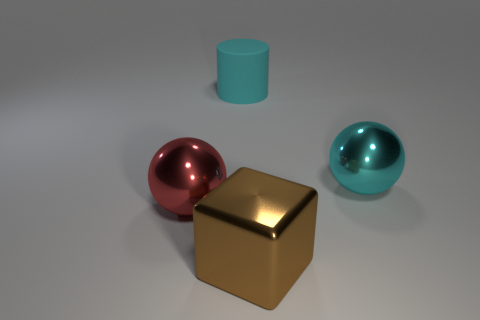Add 2 balls. How many objects exist? 6 Subtract all cylinders. How many objects are left? 3 Subtract 0 cyan cubes. How many objects are left? 4 Subtract all brown things. Subtract all big blue things. How many objects are left? 3 Add 1 big cyan rubber objects. How many big cyan rubber objects are left? 2 Add 4 large matte things. How many large matte things exist? 5 